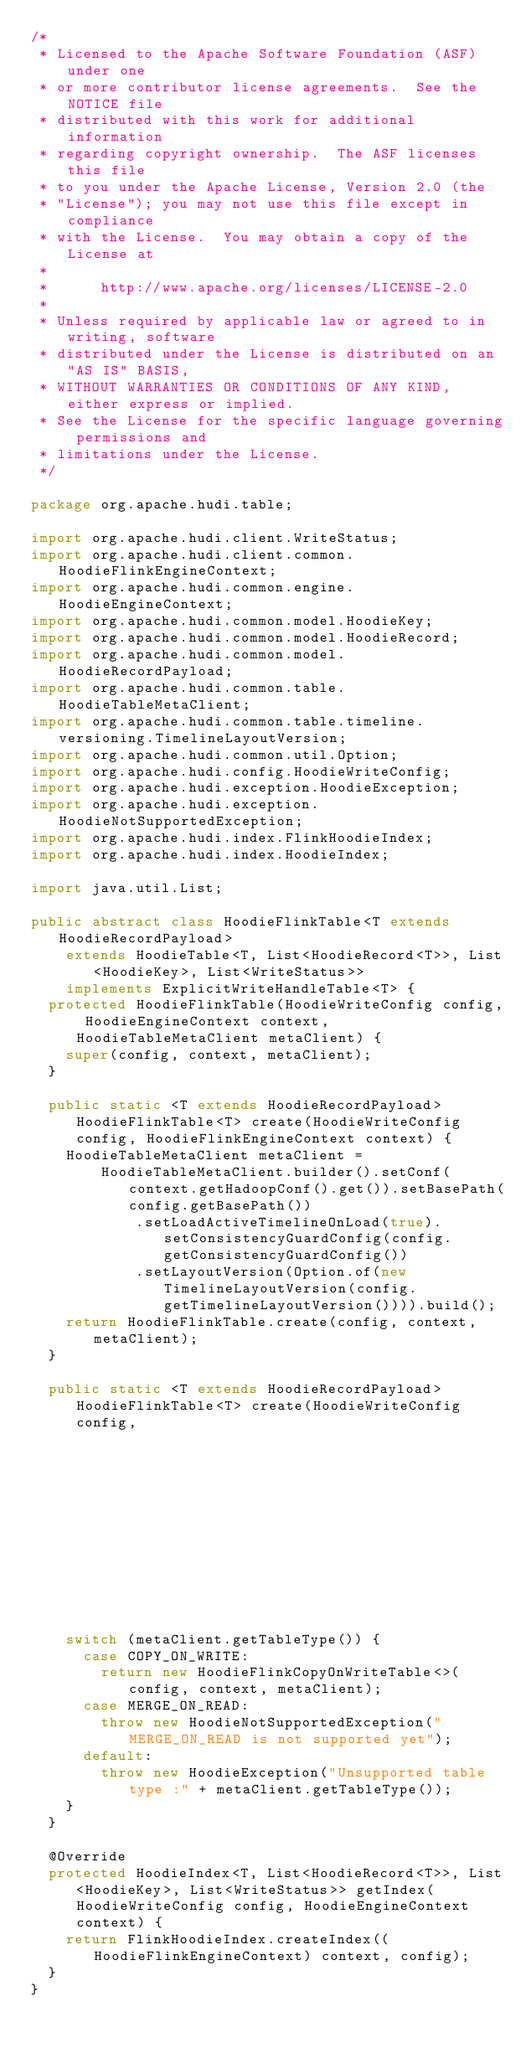<code> <loc_0><loc_0><loc_500><loc_500><_Java_>/*
 * Licensed to the Apache Software Foundation (ASF) under one
 * or more contributor license agreements.  See the NOTICE file
 * distributed with this work for additional information
 * regarding copyright ownership.  The ASF licenses this file
 * to you under the Apache License, Version 2.0 (the
 * "License"); you may not use this file except in compliance
 * with the License.  You may obtain a copy of the License at
 *
 *      http://www.apache.org/licenses/LICENSE-2.0
 *
 * Unless required by applicable law or agreed to in writing, software
 * distributed under the License is distributed on an "AS IS" BASIS,
 * WITHOUT WARRANTIES OR CONDITIONS OF ANY KIND, either express or implied.
 * See the License for the specific language governing permissions and
 * limitations under the License.
 */

package org.apache.hudi.table;

import org.apache.hudi.client.WriteStatus;
import org.apache.hudi.client.common.HoodieFlinkEngineContext;
import org.apache.hudi.common.engine.HoodieEngineContext;
import org.apache.hudi.common.model.HoodieKey;
import org.apache.hudi.common.model.HoodieRecord;
import org.apache.hudi.common.model.HoodieRecordPayload;
import org.apache.hudi.common.table.HoodieTableMetaClient;
import org.apache.hudi.common.table.timeline.versioning.TimelineLayoutVersion;
import org.apache.hudi.common.util.Option;
import org.apache.hudi.config.HoodieWriteConfig;
import org.apache.hudi.exception.HoodieException;
import org.apache.hudi.exception.HoodieNotSupportedException;
import org.apache.hudi.index.FlinkHoodieIndex;
import org.apache.hudi.index.HoodieIndex;

import java.util.List;

public abstract class HoodieFlinkTable<T extends HoodieRecordPayload>
    extends HoodieTable<T, List<HoodieRecord<T>>, List<HoodieKey>, List<WriteStatus>>
    implements ExplicitWriteHandleTable<T> {
  protected HoodieFlinkTable(HoodieWriteConfig config, HoodieEngineContext context, HoodieTableMetaClient metaClient) {
    super(config, context, metaClient);
  }

  public static <T extends HoodieRecordPayload> HoodieFlinkTable<T> create(HoodieWriteConfig config, HoodieFlinkEngineContext context) {
    HoodieTableMetaClient metaClient =
        HoodieTableMetaClient.builder().setConf(context.getHadoopConf().get()).setBasePath(config.getBasePath())
            .setLoadActiveTimelineOnLoad(true).setConsistencyGuardConfig(config.getConsistencyGuardConfig())
            .setLayoutVersion(Option.of(new TimelineLayoutVersion(config.getTimelineLayoutVersion()))).build();
    return HoodieFlinkTable.create(config, context, metaClient);
  }

  public static <T extends HoodieRecordPayload> HoodieFlinkTable<T> create(HoodieWriteConfig config,
                                                                           HoodieFlinkEngineContext context,
                                                                           HoodieTableMetaClient metaClient) {
    switch (metaClient.getTableType()) {
      case COPY_ON_WRITE:
        return new HoodieFlinkCopyOnWriteTable<>(config, context, metaClient);
      case MERGE_ON_READ:
        throw new HoodieNotSupportedException("MERGE_ON_READ is not supported yet");
      default:
        throw new HoodieException("Unsupported table type :" + metaClient.getTableType());
    }
  }

  @Override
  protected HoodieIndex<T, List<HoodieRecord<T>>, List<HoodieKey>, List<WriteStatus>> getIndex(HoodieWriteConfig config, HoodieEngineContext context) {
    return FlinkHoodieIndex.createIndex((HoodieFlinkEngineContext) context, config);
  }
}
</code> 